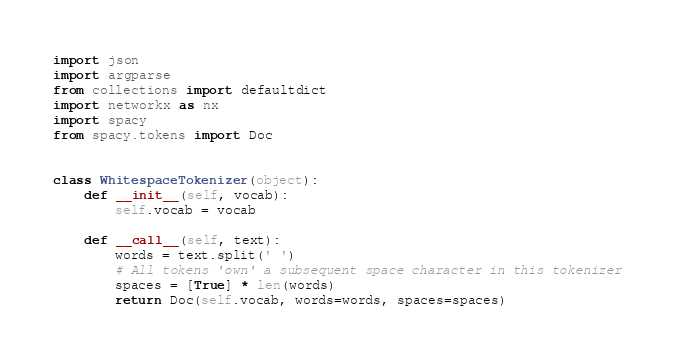Convert code to text. <code><loc_0><loc_0><loc_500><loc_500><_Python_>import json
import argparse
from collections import defaultdict
import networkx as nx
import spacy
from spacy.tokens import Doc


class WhitespaceTokenizer(object):
    def __init__(self, vocab):
        self.vocab = vocab

    def __call__(self, text):
        words = text.split(' ')
        # All tokens 'own' a subsequent space character in this tokenizer
        spaces = [True] * len(words)
        return Doc(self.vocab, words=words, spaces=spaces)
</code> 